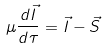Convert formula to latex. <formula><loc_0><loc_0><loc_500><loc_500>\mu \frac { d \vec { I } } { d \tau } = \vec { I } - \vec { S }</formula> 